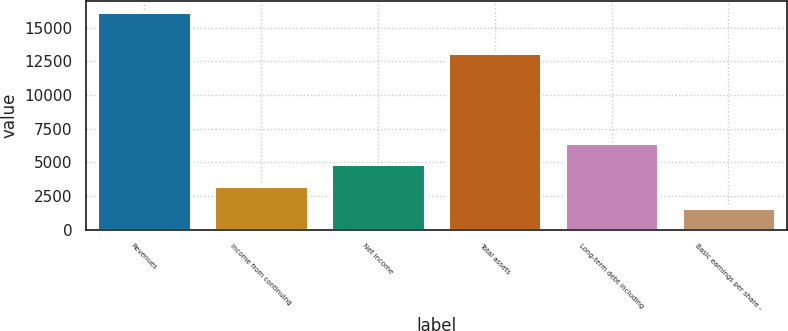Convert chart. <chart><loc_0><loc_0><loc_500><loc_500><bar_chart><fcel>Revenues<fcel>Income from continuing<fcel>Net income<fcel>Total assets<fcel>Long-term debt including<fcel>Basic earnings per share -<nl><fcel>16157.4<fcel>3233.87<fcel>4849.31<fcel>13126.1<fcel>6464.75<fcel>1618.43<nl></chart> 